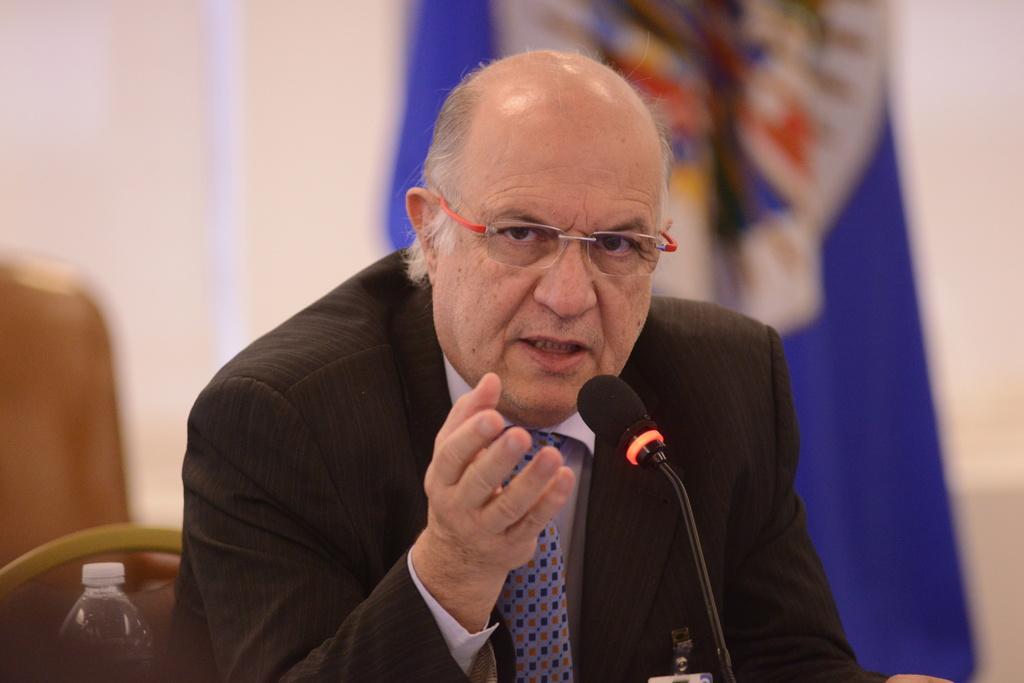In one or two sentences, can you explain what this image depicts? In this image there is a man in the middle who is sitting in the chair by wearing the black suit. In front of him there is a mic. In the background there is a flag. On the left side bottom there is a bottle. 